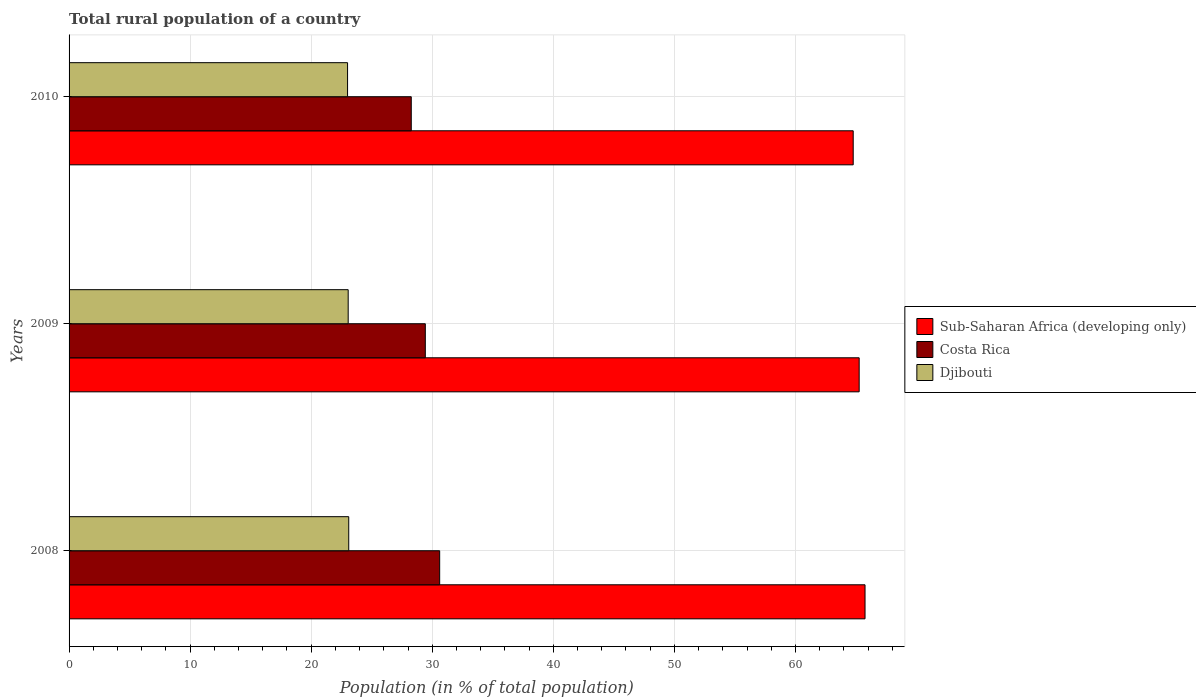How many groups of bars are there?
Your answer should be compact. 3. Are the number of bars on each tick of the Y-axis equal?
Provide a short and direct response. Yes. How many bars are there on the 1st tick from the top?
Ensure brevity in your answer.  3. How many bars are there on the 3rd tick from the bottom?
Your answer should be compact. 3. What is the rural population in Sub-Saharan Africa (developing only) in 2008?
Your response must be concise. 65.75. Across all years, what is the maximum rural population in Djibouti?
Your answer should be compact. 23.1. Across all years, what is the minimum rural population in Sub-Saharan Africa (developing only)?
Provide a succinct answer. 64.77. What is the total rural population in Djibouti in the graph?
Make the answer very short. 69.16. What is the difference between the rural population in Djibouti in 2009 and that in 2010?
Your answer should be compact. 0.05. What is the difference between the rural population in Sub-Saharan Africa (developing only) in 2010 and the rural population in Costa Rica in 2008?
Keep it short and to the point. 34.16. What is the average rural population in Sub-Saharan Africa (developing only) per year?
Your response must be concise. 65.26. In the year 2009, what is the difference between the rural population in Djibouti and rural population in Sub-Saharan Africa (developing only)?
Keep it short and to the point. -42.21. In how many years, is the rural population in Djibouti greater than 52 %?
Give a very brief answer. 0. What is the ratio of the rural population in Djibouti in 2008 to that in 2009?
Make the answer very short. 1. Is the rural population in Costa Rica in 2008 less than that in 2010?
Ensure brevity in your answer.  No. Is the difference between the rural population in Djibouti in 2008 and 2010 greater than the difference between the rural population in Sub-Saharan Africa (developing only) in 2008 and 2010?
Give a very brief answer. No. What is the difference between the highest and the second highest rural population in Djibouti?
Provide a short and direct response. 0.04. What is the difference between the highest and the lowest rural population in Costa Rica?
Provide a short and direct response. 2.35. Is the sum of the rural population in Sub-Saharan Africa (developing only) in 2008 and 2009 greater than the maximum rural population in Costa Rica across all years?
Provide a succinct answer. Yes. What does the 2nd bar from the top in 2009 represents?
Make the answer very short. Costa Rica. What does the 3rd bar from the bottom in 2008 represents?
Your response must be concise. Djibouti. How many years are there in the graph?
Offer a very short reply. 3. Are the values on the major ticks of X-axis written in scientific E-notation?
Your response must be concise. No. Does the graph contain grids?
Your response must be concise. Yes. Where does the legend appear in the graph?
Your response must be concise. Center right. What is the title of the graph?
Offer a very short reply. Total rural population of a country. Does "Singapore" appear as one of the legend labels in the graph?
Your response must be concise. No. What is the label or title of the X-axis?
Provide a short and direct response. Population (in % of total population). What is the label or title of the Y-axis?
Offer a terse response. Years. What is the Population (in % of total population) of Sub-Saharan Africa (developing only) in 2008?
Your answer should be very brief. 65.75. What is the Population (in % of total population) of Costa Rica in 2008?
Ensure brevity in your answer.  30.61. What is the Population (in % of total population) in Djibouti in 2008?
Keep it short and to the point. 23.1. What is the Population (in % of total population) in Sub-Saharan Africa (developing only) in 2009?
Give a very brief answer. 65.26. What is the Population (in % of total population) of Costa Rica in 2009?
Your answer should be compact. 29.43. What is the Population (in % of total population) in Djibouti in 2009?
Offer a terse response. 23.06. What is the Population (in % of total population) in Sub-Saharan Africa (developing only) in 2010?
Your answer should be very brief. 64.77. What is the Population (in % of total population) in Costa Rica in 2010?
Provide a short and direct response. 28.27. What is the Population (in % of total population) in Djibouti in 2010?
Keep it short and to the point. 23. Across all years, what is the maximum Population (in % of total population) of Sub-Saharan Africa (developing only)?
Make the answer very short. 65.75. Across all years, what is the maximum Population (in % of total population) of Costa Rica?
Offer a terse response. 30.61. Across all years, what is the maximum Population (in % of total population) in Djibouti?
Your answer should be very brief. 23.1. Across all years, what is the minimum Population (in % of total population) in Sub-Saharan Africa (developing only)?
Ensure brevity in your answer.  64.77. Across all years, what is the minimum Population (in % of total population) in Costa Rica?
Keep it short and to the point. 28.27. Across all years, what is the minimum Population (in % of total population) of Djibouti?
Offer a very short reply. 23. What is the total Population (in % of total population) in Sub-Saharan Africa (developing only) in the graph?
Offer a very short reply. 195.79. What is the total Population (in % of total population) of Costa Rica in the graph?
Provide a succinct answer. 88.31. What is the total Population (in % of total population) of Djibouti in the graph?
Ensure brevity in your answer.  69.16. What is the difference between the Population (in % of total population) in Sub-Saharan Africa (developing only) in 2008 and that in 2009?
Offer a very short reply. 0.48. What is the difference between the Population (in % of total population) in Costa Rica in 2008 and that in 2009?
Keep it short and to the point. 1.19. What is the difference between the Population (in % of total population) in Djibouti in 2008 and that in 2009?
Give a very brief answer. 0.04. What is the difference between the Population (in % of total population) in Sub-Saharan Africa (developing only) in 2008 and that in 2010?
Keep it short and to the point. 0.98. What is the difference between the Population (in % of total population) in Costa Rica in 2008 and that in 2010?
Offer a very short reply. 2.35. What is the difference between the Population (in % of total population) of Djibouti in 2008 and that in 2010?
Keep it short and to the point. 0.1. What is the difference between the Population (in % of total population) of Sub-Saharan Africa (developing only) in 2009 and that in 2010?
Your answer should be compact. 0.49. What is the difference between the Population (in % of total population) in Costa Rica in 2009 and that in 2010?
Your answer should be very brief. 1.16. What is the difference between the Population (in % of total population) in Djibouti in 2009 and that in 2010?
Offer a very short reply. 0.05. What is the difference between the Population (in % of total population) in Sub-Saharan Africa (developing only) in 2008 and the Population (in % of total population) in Costa Rica in 2009?
Provide a short and direct response. 36.32. What is the difference between the Population (in % of total population) in Sub-Saharan Africa (developing only) in 2008 and the Population (in % of total population) in Djibouti in 2009?
Ensure brevity in your answer.  42.69. What is the difference between the Population (in % of total population) of Costa Rica in 2008 and the Population (in % of total population) of Djibouti in 2009?
Make the answer very short. 7.56. What is the difference between the Population (in % of total population) of Sub-Saharan Africa (developing only) in 2008 and the Population (in % of total population) of Costa Rica in 2010?
Offer a very short reply. 37.48. What is the difference between the Population (in % of total population) of Sub-Saharan Africa (developing only) in 2008 and the Population (in % of total population) of Djibouti in 2010?
Provide a succinct answer. 42.75. What is the difference between the Population (in % of total population) in Costa Rica in 2008 and the Population (in % of total population) in Djibouti in 2010?
Provide a succinct answer. 7.61. What is the difference between the Population (in % of total population) of Sub-Saharan Africa (developing only) in 2009 and the Population (in % of total population) of Costa Rica in 2010?
Offer a very short reply. 37. What is the difference between the Population (in % of total population) of Sub-Saharan Africa (developing only) in 2009 and the Population (in % of total population) of Djibouti in 2010?
Ensure brevity in your answer.  42.26. What is the difference between the Population (in % of total population) of Costa Rica in 2009 and the Population (in % of total population) of Djibouti in 2010?
Provide a succinct answer. 6.42. What is the average Population (in % of total population) in Sub-Saharan Africa (developing only) per year?
Make the answer very short. 65.26. What is the average Population (in % of total population) of Costa Rica per year?
Provide a short and direct response. 29.44. What is the average Population (in % of total population) in Djibouti per year?
Make the answer very short. 23.05. In the year 2008, what is the difference between the Population (in % of total population) of Sub-Saharan Africa (developing only) and Population (in % of total population) of Costa Rica?
Your answer should be very brief. 35.14. In the year 2008, what is the difference between the Population (in % of total population) in Sub-Saharan Africa (developing only) and Population (in % of total population) in Djibouti?
Your response must be concise. 42.65. In the year 2008, what is the difference between the Population (in % of total population) of Costa Rica and Population (in % of total population) of Djibouti?
Your answer should be compact. 7.51. In the year 2009, what is the difference between the Population (in % of total population) of Sub-Saharan Africa (developing only) and Population (in % of total population) of Costa Rica?
Ensure brevity in your answer.  35.84. In the year 2009, what is the difference between the Population (in % of total population) of Sub-Saharan Africa (developing only) and Population (in % of total population) of Djibouti?
Give a very brief answer. 42.21. In the year 2009, what is the difference between the Population (in % of total population) of Costa Rica and Population (in % of total population) of Djibouti?
Offer a very short reply. 6.37. In the year 2010, what is the difference between the Population (in % of total population) of Sub-Saharan Africa (developing only) and Population (in % of total population) of Costa Rica?
Ensure brevity in your answer.  36.51. In the year 2010, what is the difference between the Population (in % of total population) in Sub-Saharan Africa (developing only) and Population (in % of total population) in Djibouti?
Keep it short and to the point. 41.77. In the year 2010, what is the difference between the Population (in % of total population) of Costa Rica and Population (in % of total population) of Djibouti?
Make the answer very short. 5.26. What is the ratio of the Population (in % of total population) of Sub-Saharan Africa (developing only) in 2008 to that in 2009?
Ensure brevity in your answer.  1.01. What is the ratio of the Population (in % of total population) of Costa Rica in 2008 to that in 2009?
Offer a terse response. 1.04. What is the ratio of the Population (in % of total population) of Djibouti in 2008 to that in 2009?
Provide a succinct answer. 1. What is the ratio of the Population (in % of total population) in Sub-Saharan Africa (developing only) in 2008 to that in 2010?
Your answer should be compact. 1.02. What is the ratio of the Population (in % of total population) in Costa Rica in 2008 to that in 2010?
Offer a very short reply. 1.08. What is the ratio of the Population (in % of total population) in Sub-Saharan Africa (developing only) in 2009 to that in 2010?
Offer a very short reply. 1.01. What is the ratio of the Population (in % of total population) of Costa Rica in 2009 to that in 2010?
Offer a very short reply. 1.04. What is the ratio of the Population (in % of total population) of Djibouti in 2009 to that in 2010?
Provide a succinct answer. 1. What is the difference between the highest and the second highest Population (in % of total population) in Sub-Saharan Africa (developing only)?
Your answer should be very brief. 0.48. What is the difference between the highest and the second highest Population (in % of total population) of Costa Rica?
Keep it short and to the point. 1.19. What is the difference between the highest and the second highest Population (in % of total population) in Djibouti?
Make the answer very short. 0.04. What is the difference between the highest and the lowest Population (in % of total population) of Sub-Saharan Africa (developing only)?
Offer a very short reply. 0.98. What is the difference between the highest and the lowest Population (in % of total population) in Costa Rica?
Give a very brief answer. 2.35. What is the difference between the highest and the lowest Population (in % of total population) of Djibouti?
Provide a short and direct response. 0.1. 